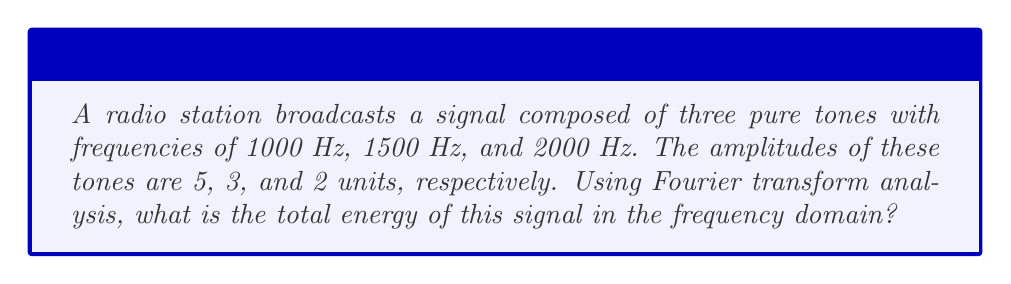Help me with this question. To solve this problem, we'll follow these steps:

1) Recall that the Fourier transform of a signal represents its frequency content. For a pure tone (sinusoid), the Fourier transform is a pair of delta functions at the positive and negative frequency of the tone.

2) In the frequency domain, the energy of a signal is proportional to the square of the magnitude of its Fourier transform.

3) For each tone, the energy is distributed equally between the positive and negative frequency components.

4) The total energy is the sum of the energies of all components.

Let's calculate:

For the 1000 Hz tone with amplitude 5:
Energy = $2 \cdot (\frac{5}{2})^2 = \frac{25}{2}$

For the 1500 Hz tone with amplitude 3:
Energy = $2 \cdot (\frac{3}{2})^2 = \frac{9}{2}$

For the 2000 Hz tone with amplitude 2:
Energy = $2 \cdot (\frac{2}{2})^2 = 2$

Total energy:
$$E_{total} = \frac{25}{2} + \frac{9}{2} + 2 = \frac{25 + 9 + 4}{2} = \frac{38}{2} = 19$$

Therefore, the total energy of the signal in the frequency domain is 19 units.
Answer: 19 units 